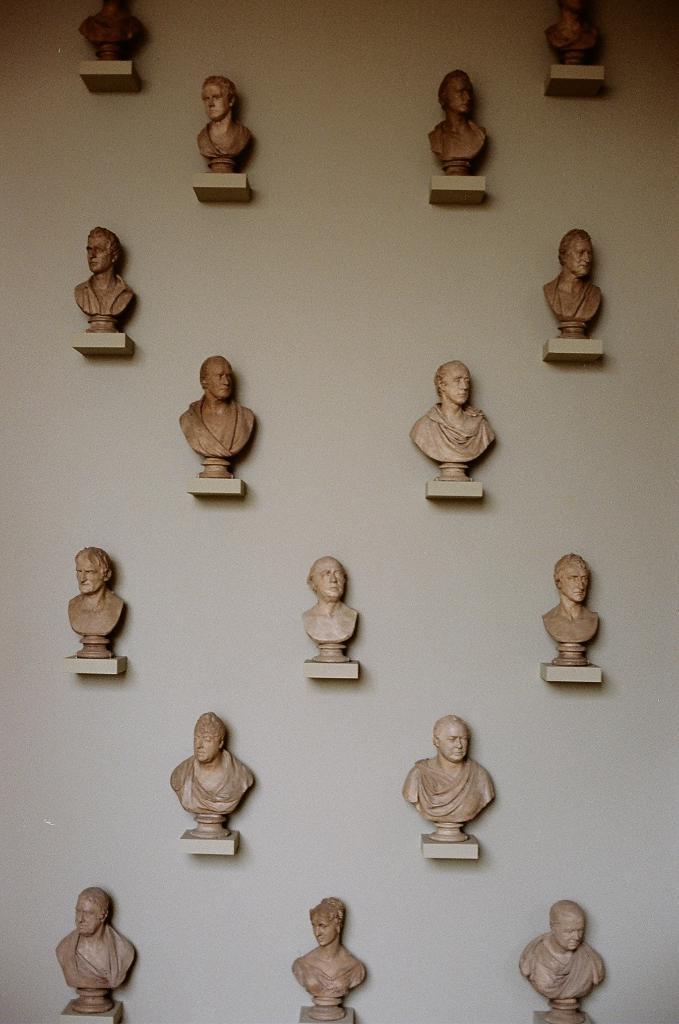How would you summarize this image in a sentence or two? In this image we can see so many statues on the wall. 